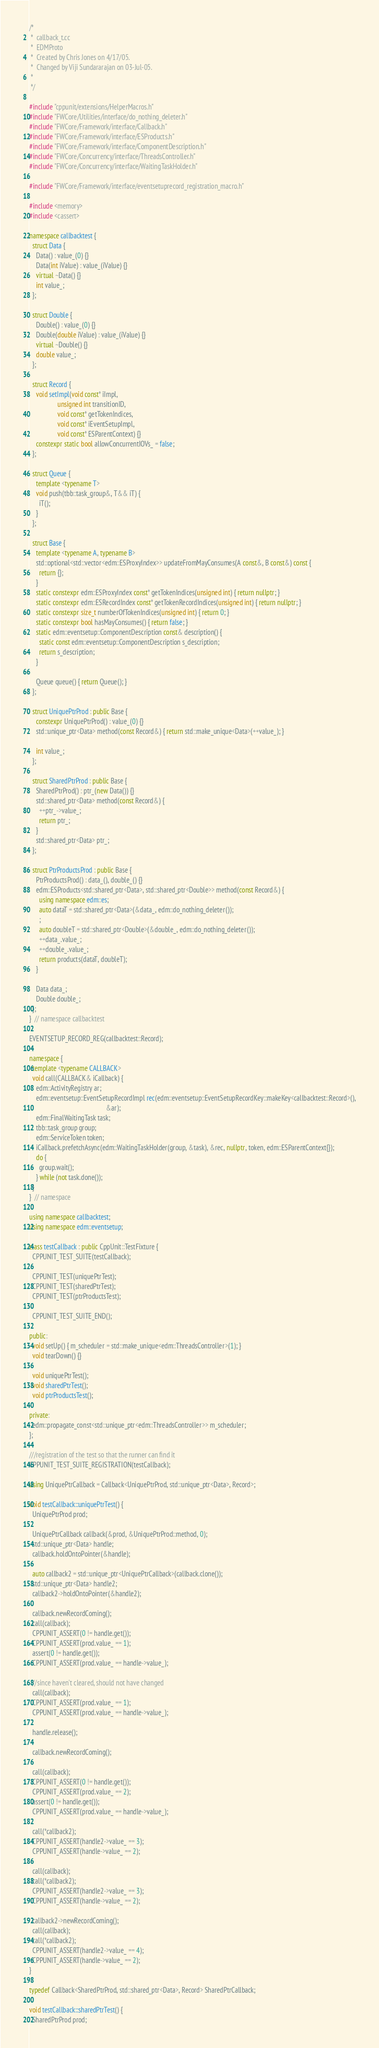<code> <loc_0><loc_0><loc_500><loc_500><_C++_>/*
 *  callback_t.cc
 *  EDMProto
 *  Created by Chris Jones on 4/17/05.
 *  Changed by Viji Sundararajan on 03-Jul-05.
 *
 */

#include "cppunit/extensions/HelperMacros.h"
#include "FWCore/Utilities/interface/do_nothing_deleter.h"
#include "FWCore/Framework/interface/Callback.h"
#include "FWCore/Framework/interface/ESProducts.h"
#include "FWCore/Framework/interface/ComponentDescription.h"
#include "FWCore/Concurrency/interface/ThreadsController.h"
#include "FWCore/Concurrency/interface/WaitingTaskHolder.h"

#include "FWCore/Framework/interface/eventsetuprecord_registration_macro.h"

#include <memory>
#include <cassert>

namespace callbacktest {
  struct Data {
    Data() : value_(0) {}
    Data(int iValue) : value_(iValue) {}
    virtual ~Data() {}
    int value_;
  };

  struct Double {
    Double() : value_(0) {}
    Double(double iValue) : value_(iValue) {}
    virtual ~Double() {}
    double value_;
  };

  struct Record {
    void setImpl(void const* iImpl,
                 unsigned int transitionID,
                 void const* getTokenIndices,
                 void const* iEventSetupImpl,
                 void const* ESParentContext) {}
    constexpr static bool allowConcurrentIOVs_ = false;
  };

  struct Queue {
    template <typename T>
    void push(tbb::task_group&, T&& iT) {
      iT();
    }
  };

  struct Base {
    template <typename A, typename B>
    std::optional<std::vector<edm::ESProxyIndex>> updateFromMayConsumes(A const&, B const&) const {
      return {};
    }
    static constexpr edm::ESProxyIndex const* getTokenIndices(unsigned int) { return nullptr; }
    static constexpr edm::ESRecordIndex const* getTokenRecordIndices(unsigned int) { return nullptr; }
    static constexpr size_t numberOfTokenIndices(unsigned int) { return 0; }
    static constexpr bool hasMayConsumes() { return false; }
    static edm::eventsetup::ComponentDescription const& description() {
      static const edm::eventsetup::ComponentDescription s_description;
      return s_description;
    }

    Queue queue() { return Queue(); }
  };

  struct UniquePtrProd : public Base {
    constexpr UniquePtrProd() : value_(0) {}
    std::unique_ptr<Data> method(const Record&) { return std::make_unique<Data>(++value_); }

    int value_;
  };

  struct SharedPtrProd : public Base {
    SharedPtrProd() : ptr_(new Data()) {}
    std::shared_ptr<Data> method(const Record&) {
      ++ptr_->value_;
      return ptr_;
    }
    std::shared_ptr<Data> ptr_;
  };

  struct PtrProductsProd : public Base {
    PtrProductsProd() : data_(), double_() {}
    edm::ESProducts<std::shared_ptr<Data>, std::shared_ptr<Double>> method(const Record&) {
      using namespace edm::es;
      auto dataT = std::shared_ptr<Data>(&data_, edm::do_nothing_deleter());
      ;
      auto doubleT = std::shared_ptr<Double>(&double_, edm::do_nothing_deleter());
      ++data_.value_;
      ++double_.value_;
      return products(dataT, doubleT);
    }

    Data data_;
    Double double_;
  };
}  // namespace callbacktest

EVENTSETUP_RECORD_REG(callbacktest::Record);

namespace {
  template <typename CALLBACK>
  void call(CALLBACK& iCallback) {
    edm::ActivityRegistry ar;
    edm::eventsetup::EventSetupRecordImpl rec(edm::eventsetup::EventSetupRecordKey::makeKey<callbacktest::Record>(),
                                              &ar);
    edm::FinalWaitingTask task;
    tbb::task_group group;
    edm::ServiceToken token;
    iCallback.prefetchAsync(edm::WaitingTaskHolder(group, &task), &rec, nullptr, token, edm::ESParentContext{});
    do {
      group.wait();
    } while (not task.done());
  }
}  // namespace

using namespace callbacktest;
using namespace edm::eventsetup;

class testCallback : public CppUnit::TestFixture {
  CPPUNIT_TEST_SUITE(testCallback);

  CPPUNIT_TEST(uniquePtrTest);
  CPPUNIT_TEST(sharedPtrTest);
  CPPUNIT_TEST(ptrProductsTest);

  CPPUNIT_TEST_SUITE_END();

public:
  void setUp() { m_scheduler = std::make_unique<edm::ThreadsController>(1); }
  void tearDown() {}

  void uniquePtrTest();
  void sharedPtrTest();
  void ptrProductsTest();

private:
  edm::propagate_const<std::unique_ptr<edm::ThreadsController>> m_scheduler;
};

///registration of the test so that the runner can find it
CPPUNIT_TEST_SUITE_REGISTRATION(testCallback);

using UniquePtrCallback = Callback<UniquePtrProd, std::unique_ptr<Data>, Record>;

void testCallback::uniquePtrTest() {
  UniquePtrProd prod;

  UniquePtrCallback callback(&prod, &UniquePtrProd::method, 0);
  std::unique_ptr<Data> handle;
  callback.holdOntoPointer(&handle);

  auto callback2 = std::unique_ptr<UniquePtrCallback>(callback.clone());
  std::unique_ptr<Data> handle2;
  callback2->holdOntoPointer(&handle2);

  callback.newRecordComing();
  call(callback);
  CPPUNIT_ASSERT(0 != handle.get());
  CPPUNIT_ASSERT(prod.value_ == 1);
  assert(0 != handle.get());
  CPPUNIT_ASSERT(prod.value_ == handle->value_);

  //since haven't cleared, should not have changed
  call(callback);
  CPPUNIT_ASSERT(prod.value_ == 1);
  CPPUNIT_ASSERT(prod.value_ == handle->value_);

  handle.release();

  callback.newRecordComing();

  call(callback);
  CPPUNIT_ASSERT(0 != handle.get());
  CPPUNIT_ASSERT(prod.value_ == 2);
  assert(0 != handle.get());
  CPPUNIT_ASSERT(prod.value_ == handle->value_);

  call(*callback2);
  CPPUNIT_ASSERT(handle2->value_ == 3);
  CPPUNIT_ASSERT(handle->value_ == 2);

  call(callback);
  call(*callback2);
  CPPUNIT_ASSERT(handle2->value_ == 3);
  CPPUNIT_ASSERT(handle->value_ == 2);

  callback2->newRecordComing();
  call(callback);
  call(*callback2);
  CPPUNIT_ASSERT(handle2->value_ == 4);
  CPPUNIT_ASSERT(handle->value_ == 2);
}

typedef Callback<SharedPtrProd, std::shared_ptr<Data>, Record> SharedPtrCallback;

void testCallback::sharedPtrTest() {
  SharedPtrProd prod;
</code> 